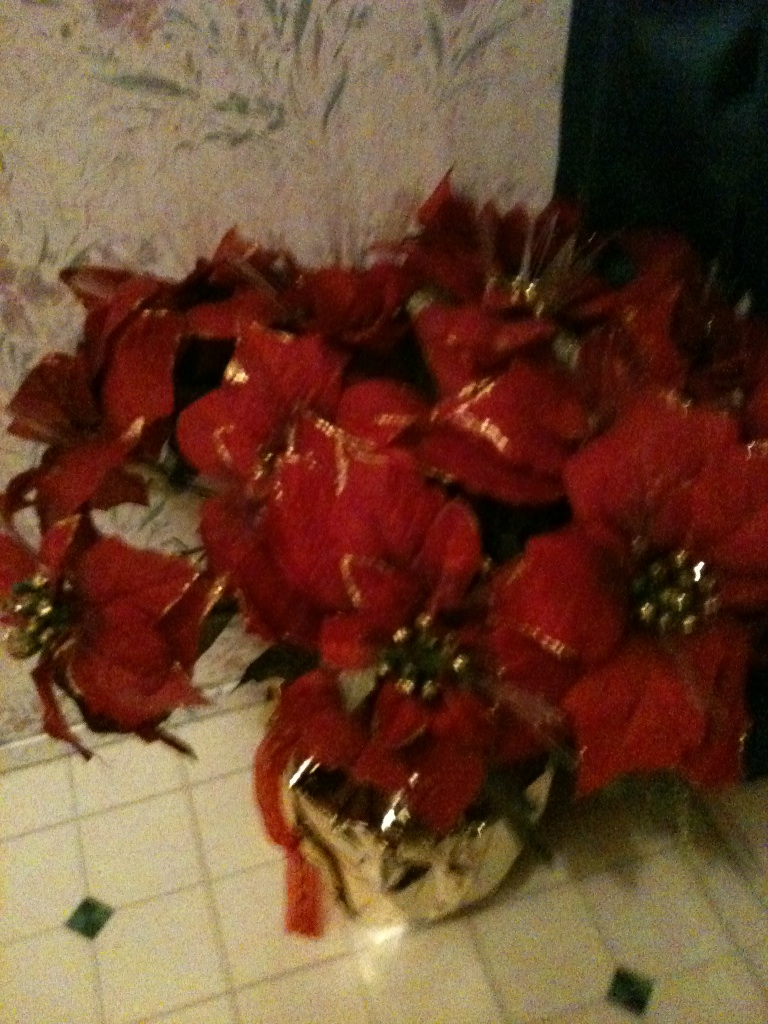Describe the ideal setting or scenario where this flower arrangement would be the most impactful. The ideal setting for this poinsettia arrangement would be a cozy, warmly-lit living room decorated for the holidays. Picture a crackling fireplace, stockings hung with care on the mantel, and a decorated Christmas tree twinkling in the background. This flower arrangement would be placed prominently on a polished wooden coffee table, surrounded by warm, comfy seating where family and friends gather to share stories, laughter, and festive treats. The rich hues of the poinsettias would be complemented by the soft glow of fairy lights, creating a heartwarming and inviting atmosphere that embodies the spirit of the season. 